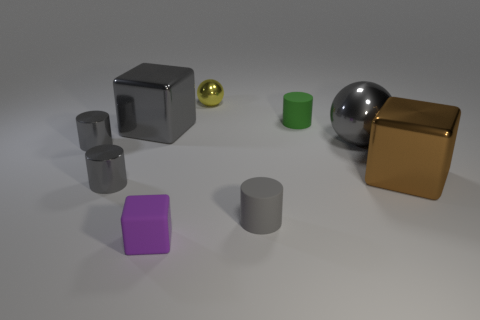Are there any small blue metal spheres?
Your answer should be compact. No. What is the size of the gray object that is the same shape as the brown shiny object?
Offer a very short reply. Large. There is a ball that is behind the small green cylinder; what size is it?
Keep it short and to the point. Small. Are there more cylinders behind the tiny gray rubber cylinder than large cubes?
Provide a short and direct response. Yes. What is the shape of the yellow object?
Your response must be concise. Sphere. Do the shiny block to the right of the tiny metallic ball and the shiny cube on the left side of the tiny matte cube have the same color?
Your answer should be compact. No. Does the small yellow thing have the same shape as the big brown metal object?
Offer a terse response. No. Is there anything else that is the same shape as the brown thing?
Give a very brief answer. Yes. Is the material of the large block right of the small block the same as the green thing?
Give a very brief answer. No. What shape is the gray metal thing that is behind the large brown cube and in front of the big gray ball?
Provide a short and direct response. Cylinder. 